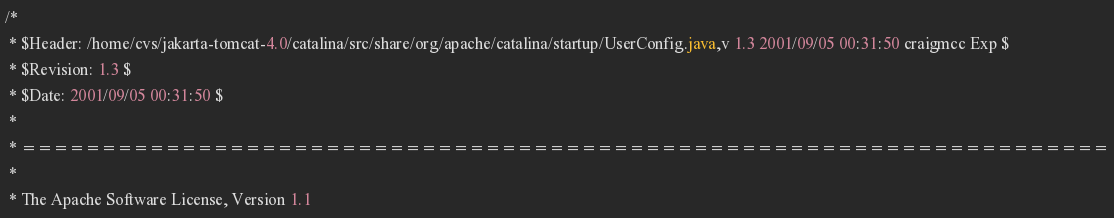Convert code to text. <code><loc_0><loc_0><loc_500><loc_500><_Java_>/*
 * $Header: /home/cvs/jakarta-tomcat-4.0/catalina/src/share/org/apache/catalina/startup/UserConfig.java,v 1.3 2001/09/05 00:31:50 craigmcc Exp $
 * $Revision: 1.3 $
 * $Date: 2001/09/05 00:31:50 $
 *
 * ====================================================================
 *
 * The Apache Software License, Version 1.1</code> 